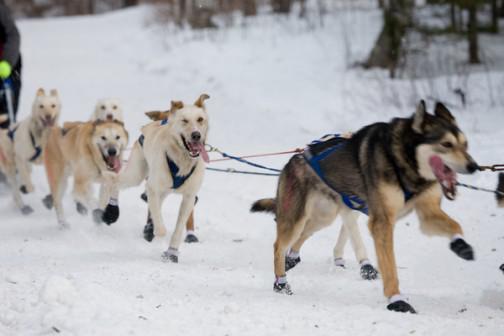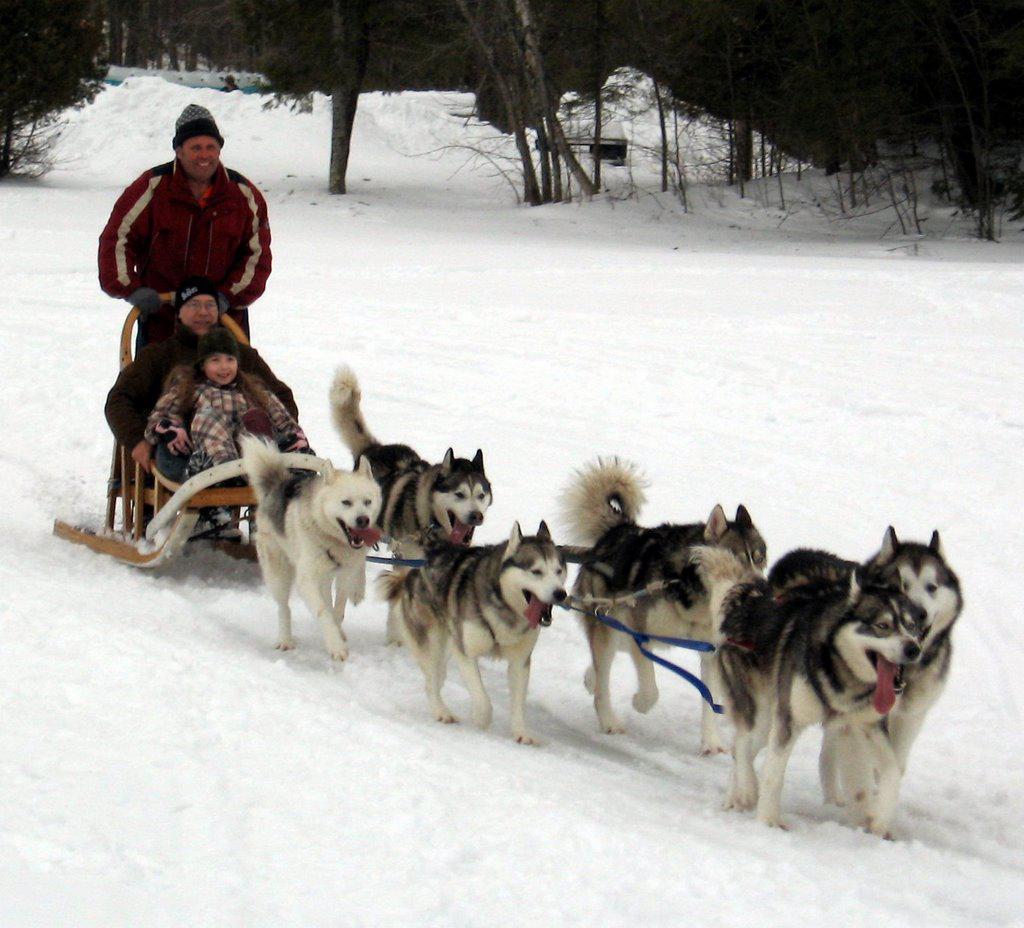The first image is the image on the left, the second image is the image on the right. For the images shown, is this caption "In at least one image there are at least two people being pulled by at least 6 sled dogs." true? Answer yes or no. Yes. The first image is the image on the left, the second image is the image on the right. Analyze the images presented: Is the assertion "One of the people on the sleds is wearing a bright blue coat." valid? Answer yes or no. No. 